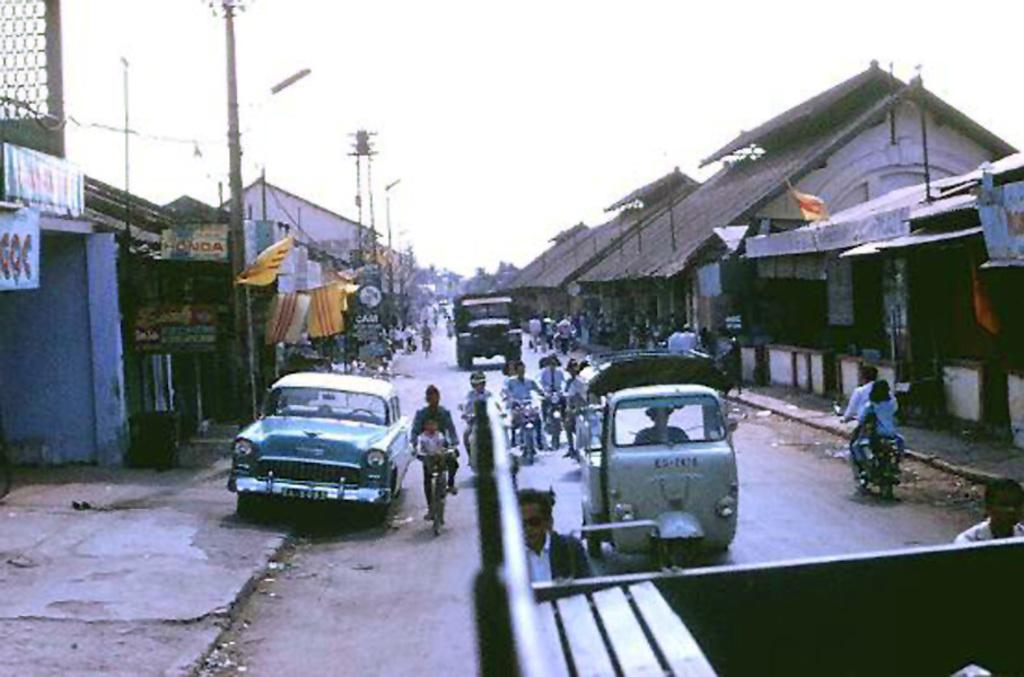What types of transportation can be seen on the road in the image? There are vehicles on the road in the image. What are some of the activities people are doing in the image? People are walking and riding bicycles in the image. What structures can be seen in the image? There are poles and buildings in the image. What is visible at the top of the image? The sky is visible at the top of the image. Where is the glass of water located in the image? There is no glass of water present in the image. What type of division can be seen between the buildings in the image? There is no specific division mentioned between the buildings in the image. 